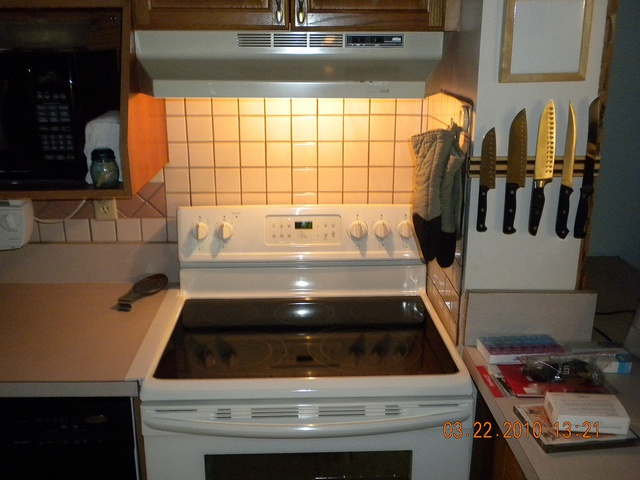Describe the objects in this image and their specific colors. I can see oven in black, gray, and darkgray tones, microwave in black, gray, and darkblue tones, book in black, gray, and maroon tones, knife in black, maroon, and gray tones, and knife in black, olive, and tan tones in this image. 